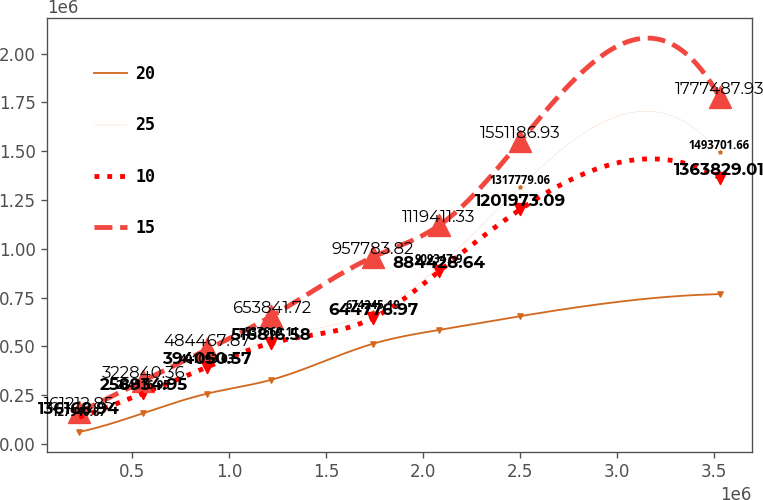Convert chart. <chart><loc_0><loc_0><loc_500><loc_500><line_chart><ecel><fcel>20<fcel>25<fcel>10<fcel>15<nl><fcel>225702<fcel>60454.2<fcel>127941<fcel>136169<fcel>161213<nl><fcel>556212<fcel>157183<fcel>264517<fcel>258935<fcel>322840<nl><fcel>886723<fcel>257506<fcel>401093<fcel>394051<fcel>484468<nl><fcel>1.21723e+06<fcel>328205<fcel>537669<fcel>516817<fcel>653842<nl><fcel>1.74209e+06<fcel>513039<fcel>674245<fcel>644777<fcel>957784<nl><fcel>2.08282e+06<fcel>583737<fcel>909348<fcel>884429<fcel>1.11941e+06<nl><fcel>2.50227e+06<fcel>654436<fcel>1.31778e+06<fcel>1.20197e+06<fcel>1.55119e+06<nl><fcel>3.53081e+06<fcel>767443<fcel>1.4937e+06<fcel>1.36383e+06<fcel>1.77749e+06<nl></chart> 